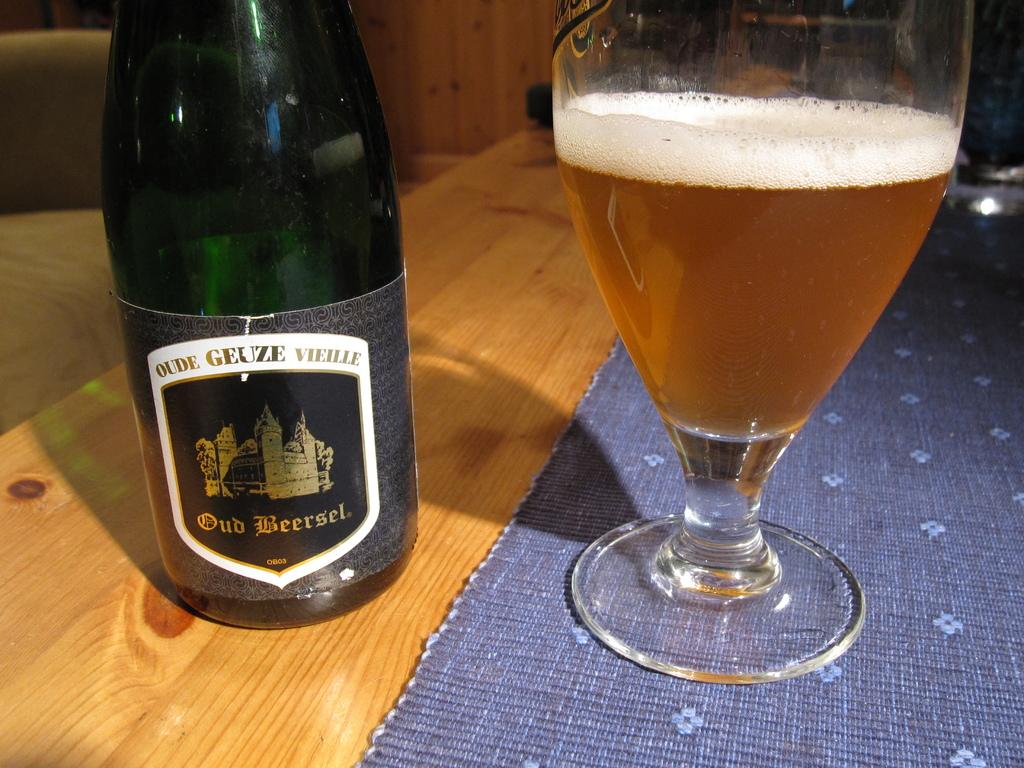<image>
Provide a brief description of the given image. A glass of beer and a bottle of Olde Geuze Vielle. 